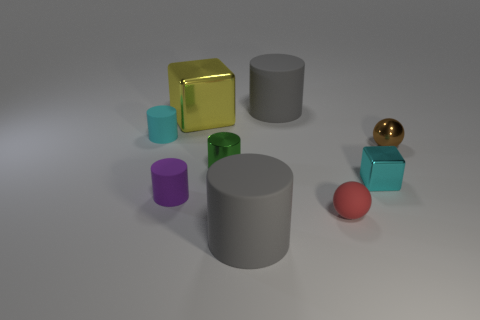Subtract all purple cylinders. How many cylinders are left? 4 Subtract all green metal cylinders. How many cylinders are left? 4 Subtract all yellow cylinders. Subtract all gray blocks. How many cylinders are left? 5 Subtract all spheres. How many objects are left? 7 Subtract all green metallic things. Subtract all big yellow metallic things. How many objects are left? 7 Add 2 tiny metallic cubes. How many tiny metallic cubes are left? 3 Add 2 blue metallic balls. How many blue metallic balls exist? 2 Subtract 0 yellow spheres. How many objects are left? 9 